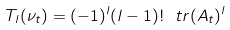Convert formula to latex. <formula><loc_0><loc_0><loc_500><loc_500>T _ { l } ( \nu _ { t } ) = ( - 1 ) ^ { l } ( l - 1 ) ! \ t r ( A _ { t } ) ^ { l }</formula> 